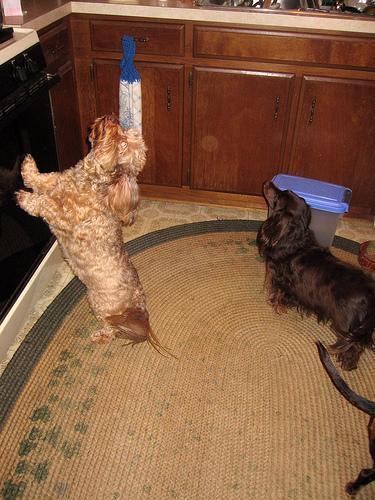How many dogs do you see?
Give a very brief answer. 2. 